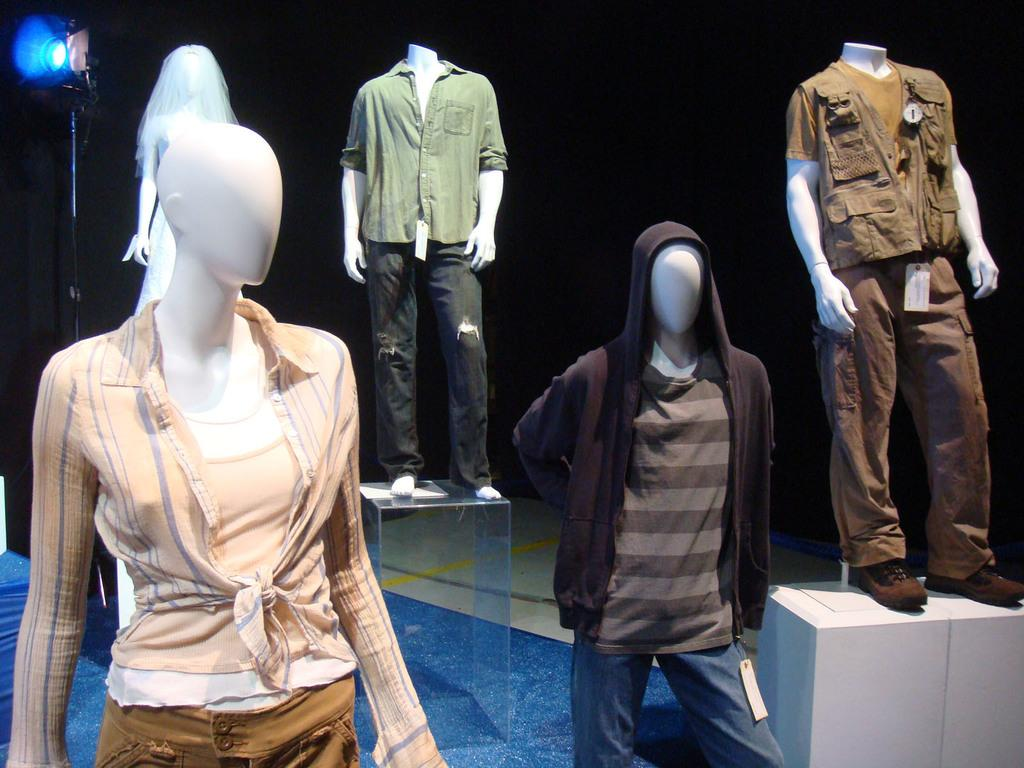What is the main subject of the image? The main subject of the image is mannequins with clothes. How are the mannequins positioned in the image? Some mannequins are on stands in the image. What information can be found on the mannequins? There are rate tags in the image. What is the color of the background in the image? The background of the image is dark. What is located on the left side of the image? There is a light with a stand on the left side of the image. What type of waves can be seen crashing on the shore in the image? There are no waves or shore present in the image; it features mannequins with clothes and rate tags. What sense is being stimulated by the mannequins in the image? The image does not stimulate any specific sense; it is a visual representation of mannequins with clothes. 